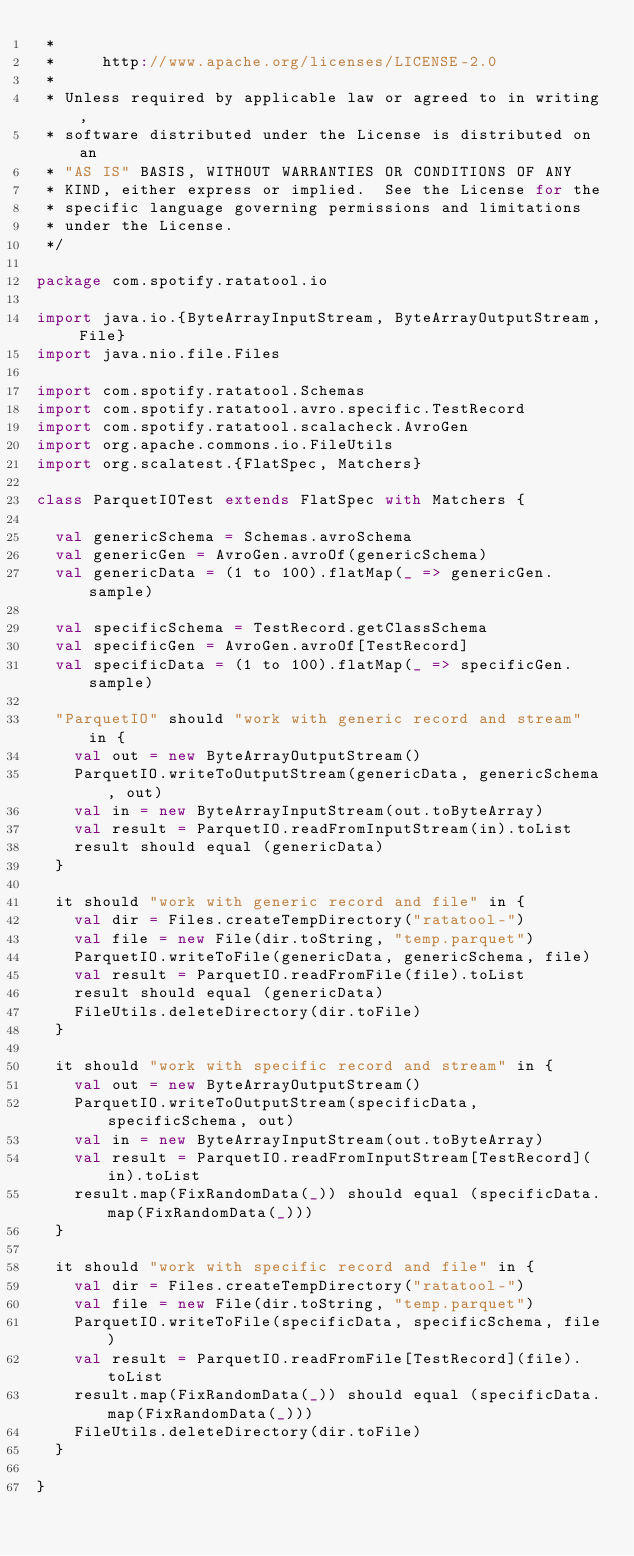Convert code to text. <code><loc_0><loc_0><loc_500><loc_500><_Scala_> *
 *     http://www.apache.org/licenses/LICENSE-2.0
 *
 * Unless required by applicable law or agreed to in writing,
 * software distributed under the License is distributed on an
 * "AS IS" BASIS, WITHOUT WARRANTIES OR CONDITIONS OF ANY
 * KIND, either express or implied.  See the License for the
 * specific language governing permissions and limitations
 * under the License.
 */

package com.spotify.ratatool.io

import java.io.{ByteArrayInputStream, ByteArrayOutputStream, File}
import java.nio.file.Files

import com.spotify.ratatool.Schemas
import com.spotify.ratatool.avro.specific.TestRecord
import com.spotify.ratatool.scalacheck.AvroGen
import org.apache.commons.io.FileUtils
import org.scalatest.{FlatSpec, Matchers}

class ParquetIOTest extends FlatSpec with Matchers {

  val genericSchema = Schemas.avroSchema
  val genericGen = AvroGen.avroOf(genericSchema)
  val genericData = (1 to 100).flatMap(_ => genericGen.sample)

  val specificSchema = TestRecord.getClassSchema
  val specificGen = AvroGen.avroOf[TestRecord]
  val specificData = (1 to 100).flatMap(_ => specificGen.sample)

  "ParquetIO" should "work with generic record and stream" in {
    val out = new ByteArrayOutputStream()
    ParquetIO.writeToOutputStream(genericData, genericSchema, out)
    val in = new ByteArrayInputStream(out.toByteArray)
    val result = ParquetIO.readFromInputStream(in).toList
    result should equal (genericData)
  }

  it should "work with generic record and file" in {
    val dir = Files.createTempDirectory("ratatool-")
    val file = new File(dir.toString, "temp.parquet")
    ParquetIO.writeToFile(genericData, genericSchema, file)
    val result = ParquetIO.readFromFile(file).toList
    result should equal (genericData)
    FileUtils.deleteDirectory(dir.toFile)
  }

  it should "work with specific record and stream" in {
    val out = new ByteArrayOutputStream()
    ParquetIO.writeToOutputStream(specificData, specificSchema, out)
    val in = new ByteArrayInputStream(out.toByteArray)
    val result = ParquetIO.readFromInputStream[TestRecord](in).toList
    result.map(FixRandomData(_)) should equal (specificData.map(FixRandomData(_)))
  }

  it should "work with specific record and file" in {
    val dir = Files.createTempDirectory("ratatool-")
    val file = new File(dir.toString, "temp.parquet")
    ParquetIO.writeToFile(specificData, specificSchema, file)
    val result = ParquetIO.readFromFile[TestRecord](file).toList
    result.map(FixRandomData(_)) should equal (specificData.map(FixRandomData(_)))
    FileUtils.deleteDirectory(dir.toFile)
  }

}
</code> 